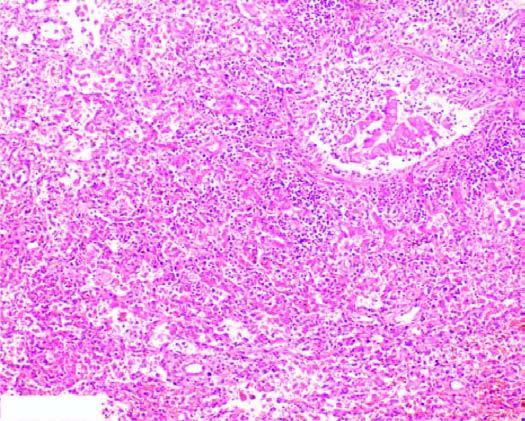what are thickened due to congested capillaries and neutrophilic infiltrate?
Answer the question using a single word or phrase. Alveolar septa 